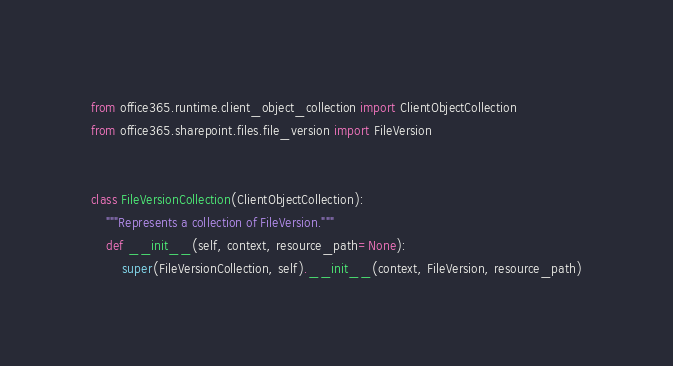<code> <loc_0><loc_0><loc_500><loc_500><_Python_>from office365.runtime.client_object_collection import ClientObjectCollection
from office365.sharepoint.files.file_version import FileVersion


class FileVersionCollection(ClientObjectCollection):
    """Represents a collection of FileVersion."""
    def __init__(self, context, resource_path=None):
        super(FileVersionCollection, self).__init__(context, FileVersion, resource_path)
</code> 